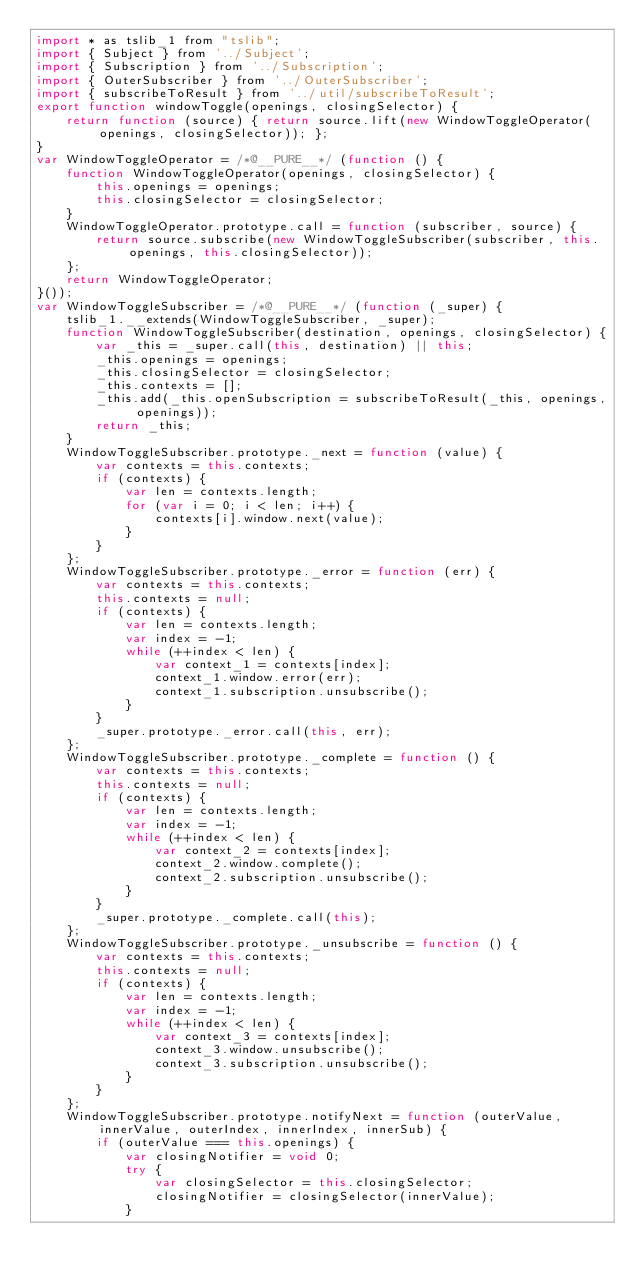<code> <loc_0><loc_0><loc_500><loc_500><_JavaScript_>import * as tslib_1 from "tslib";
import { Subject } from '../Subject';
import { Subscription } from '../Subscription';
import { OuterSubscriber } from '../OuterSubscriber';
import { subscribeToResult } from '../util/subscribeToResult';
export function windowToggle(openings, closingSelector) {
    return function (source) { return source.lift(new WindowToggleOperator(openings, closingSelector)); };
}
var WindowToggleOperator = /*@__PURE__*/ (function () {
    function WindowToggleOperator(openings, closingSelector) {
        this.openings = openings;
        this.closingSelector = closingSelector;
    }
    WindowToggleOperator.prototype.call = function (subscriber, source) {
        return source.subscribe(new WindowToggleSubscriber(subscriber, this.openings, this.closingSelector));
    };
    return WindowToggleOperator;
}());
var WindowToggleSubscriber = /*@__PURE__*/ (function (_super) {
    tslib_1.__extends(WindowToggleSubscriber, _super);
    function WindowToggleSubscriber(destination, openings, closingSelector) {
        var _this = _super.call(this, destination) || this;
        _this.openings = openings;
        _this.closingSelector = closingSelector;
        _this.contexts = [];
        _this.add(_this.openSubscription = subscribeToResult(_this, openings, openings));
        return _this;
    }
    WindowToggleSubscriber.prototype._next = function (value) {
        var contexts = this.contexts;
        if (contexts) {
            var len = contexts.length;
            for (var i = 0; i < len; i++) {
                contexts[i].window.next(value);
            }
        }
    };
    WindowToggleSubscriber.prototype._error = function (err) {
        var contexts = this.contexts;
        this.contexts = null;
        if (contexts) {
            var len = contexts.length;
            var index = -1;
            while (++index < len) {
                var context_1 = contexts[index];
                context_1.window.error(err);
                context_1.subscription.unsubscribe();
            }
        }
        _super.prototype._error.call(this, err);
    };
    WindowToggleSubscriber.prototype._complete = function () {
        var contexts = this.contexts;
        this.contexts = null;
        if (contexts) {
            var len = contexts.length;
            var index = -1;
            while (++index < len) {
                var context_2 = contexts[index];
                context_2.window.complete();
                context_2.subscription.unsubscribe();
            }
        }
        _super.prototype._complete.call(this);
    };
    WindowToggleSubscriber.prototype._unsubscribe = function () {
        var contexts = this.contexts;
        this.contexts = null;
        if (contexts) {
            var len = contexts.length;
            var index = -1;
            while (++index < len) {
                var context_3 = contexts[index];
                context_3.window.unsubscribe();
                context_3.subscription.unsubscribe();
            }
        }
    };
    WindowToggleSubscriber.prototype.notifyNext = function (outerValue, innerValue, outerIndex, innerIndex, innerSub) {
        if (outerValue === this.openings) {
            var closingNotifier = void 0;
            try {
                var closingSelector = this.closingSelector;
                closingNotifier = closingSelector(innerValue);
            }</code> 